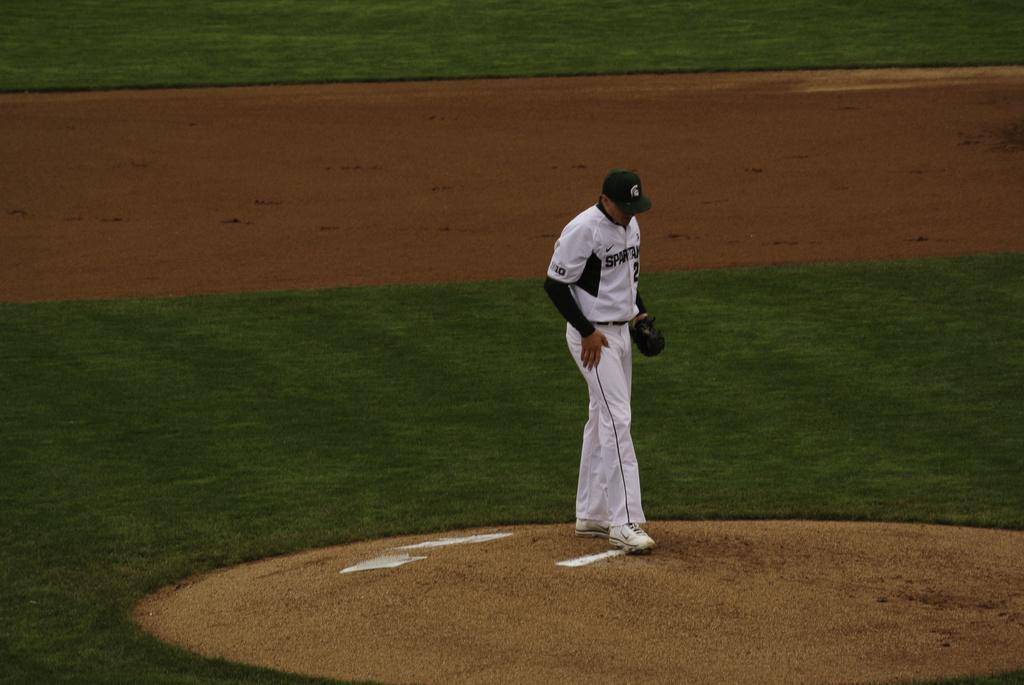Please provide a concise description of this image. There is a man wore glove and cap. We can see grass and ground. 